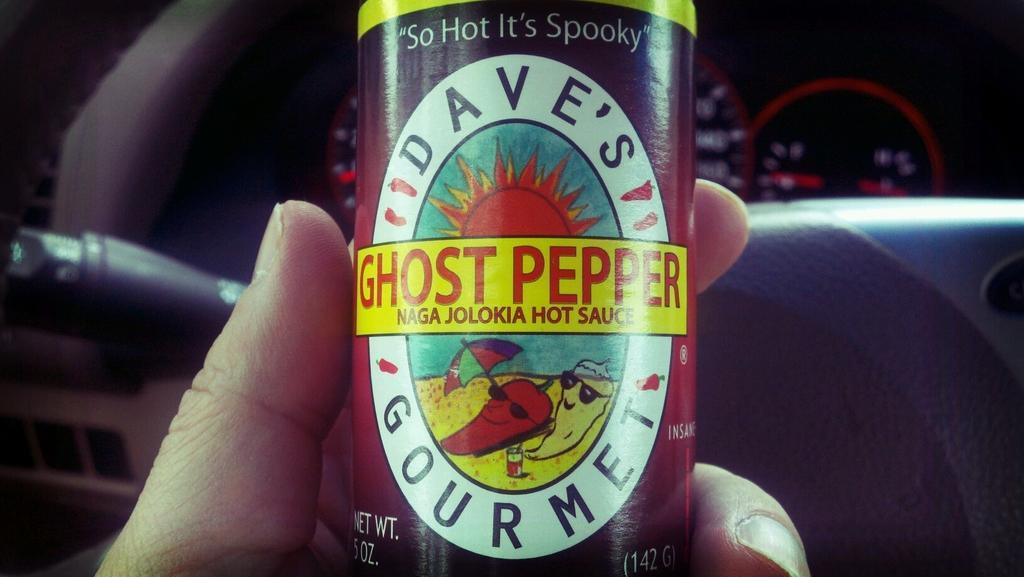Please provide a concise description of this image. In this image I can see a person's hand holding an object on which I can see some text. This seems to be an inside view of a vehicle. On the right side there is a steering and speedometer. 